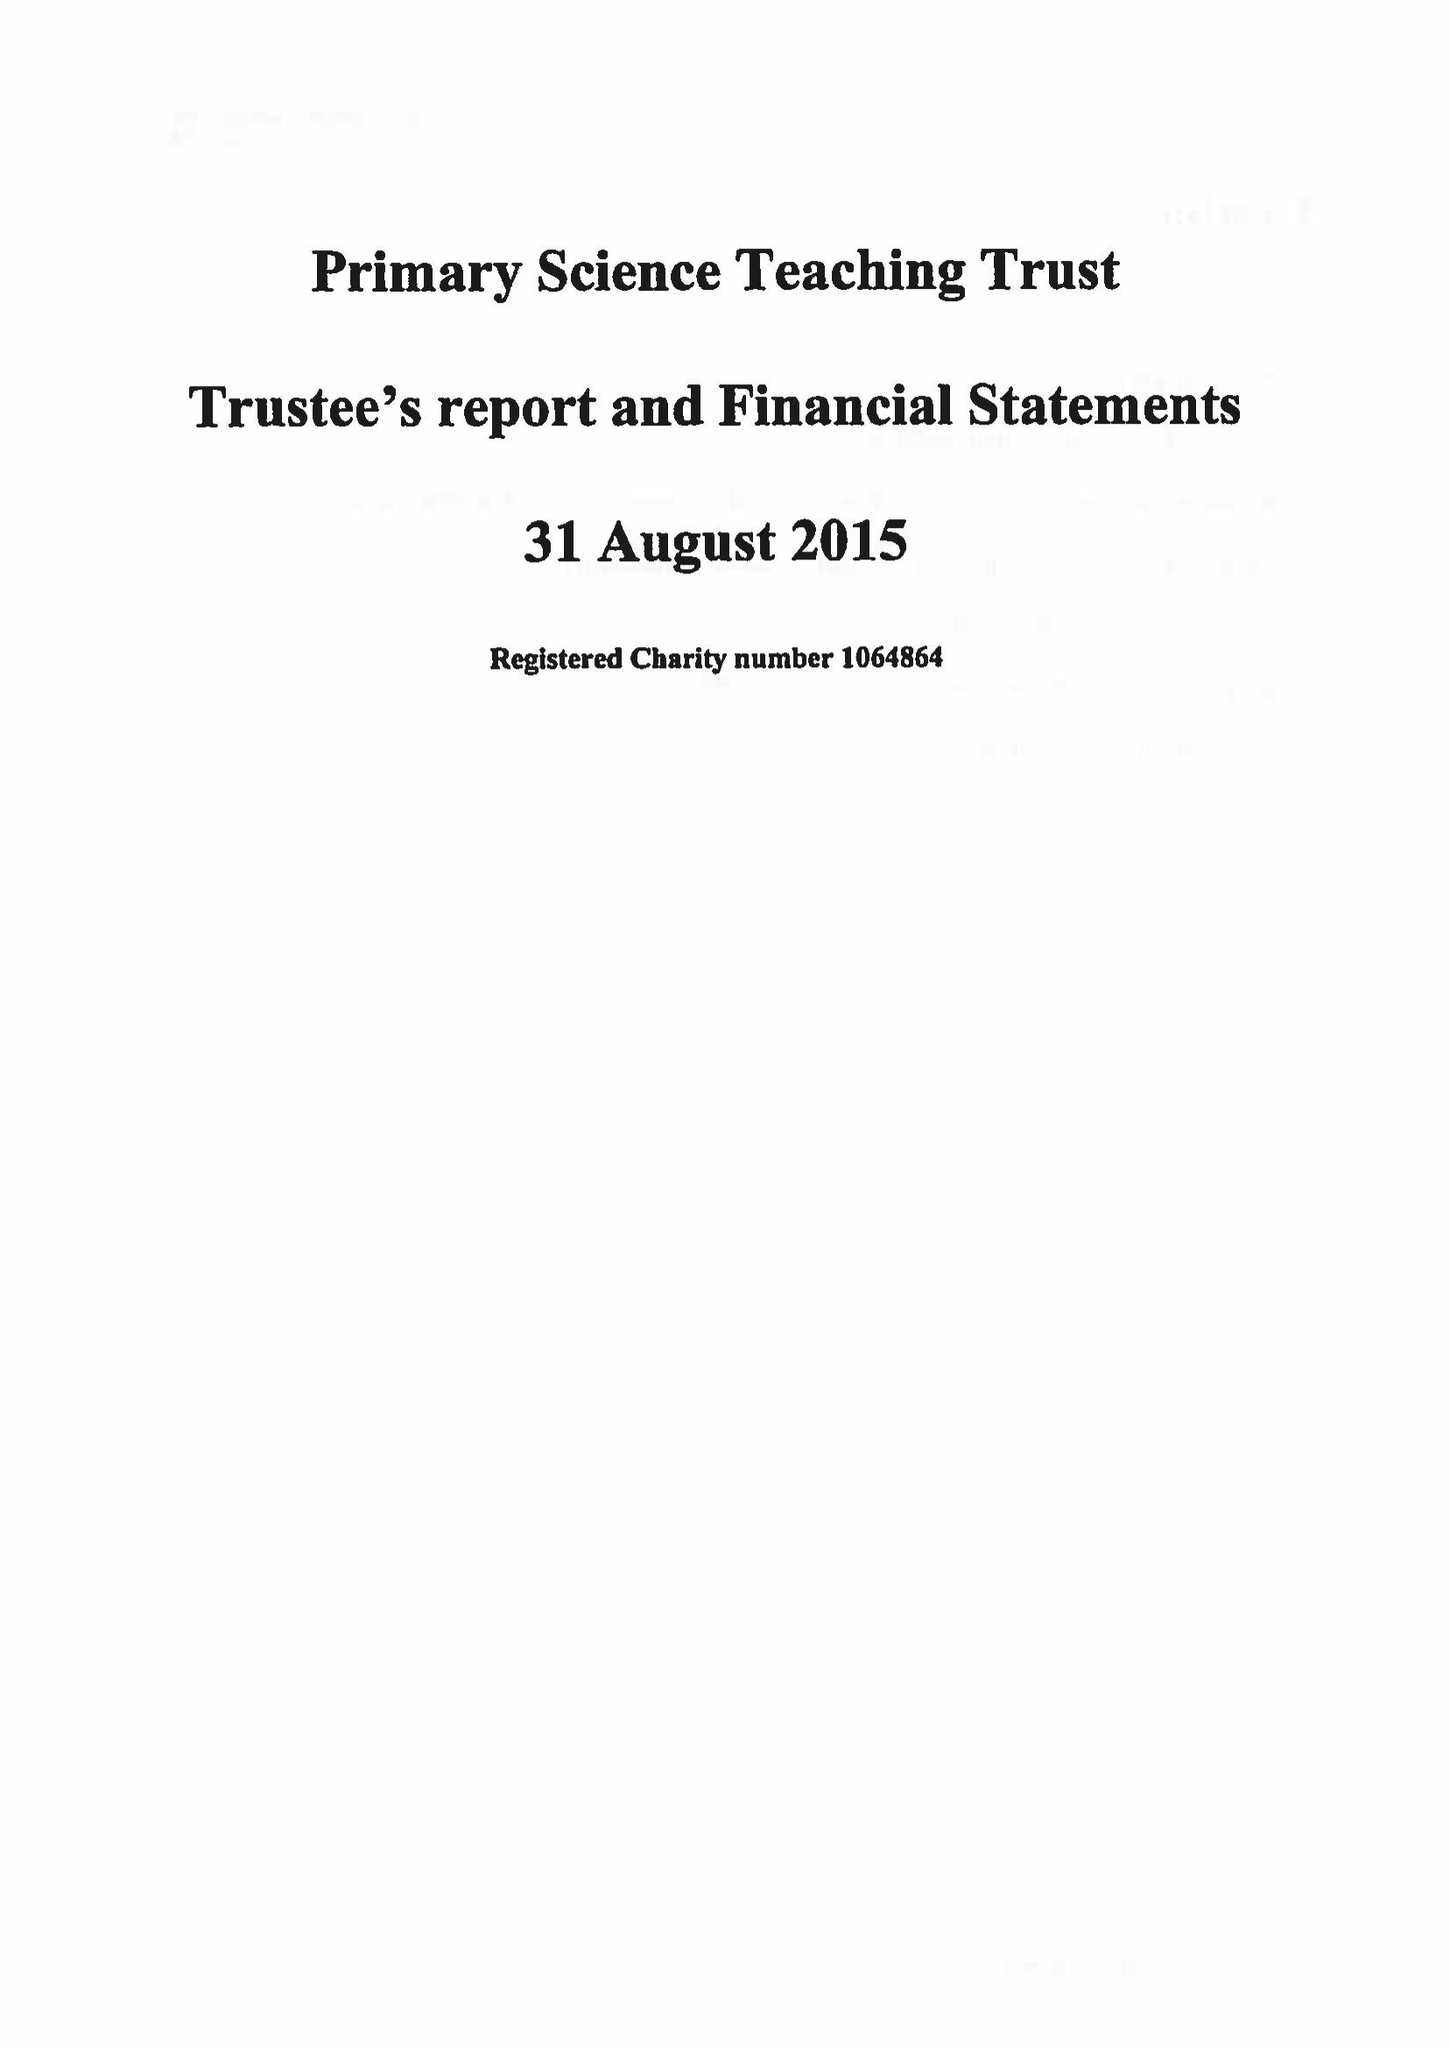What is the value for the income_annually_in_british_pounds?
Answer the question using a single word or phrase. 78104.00 